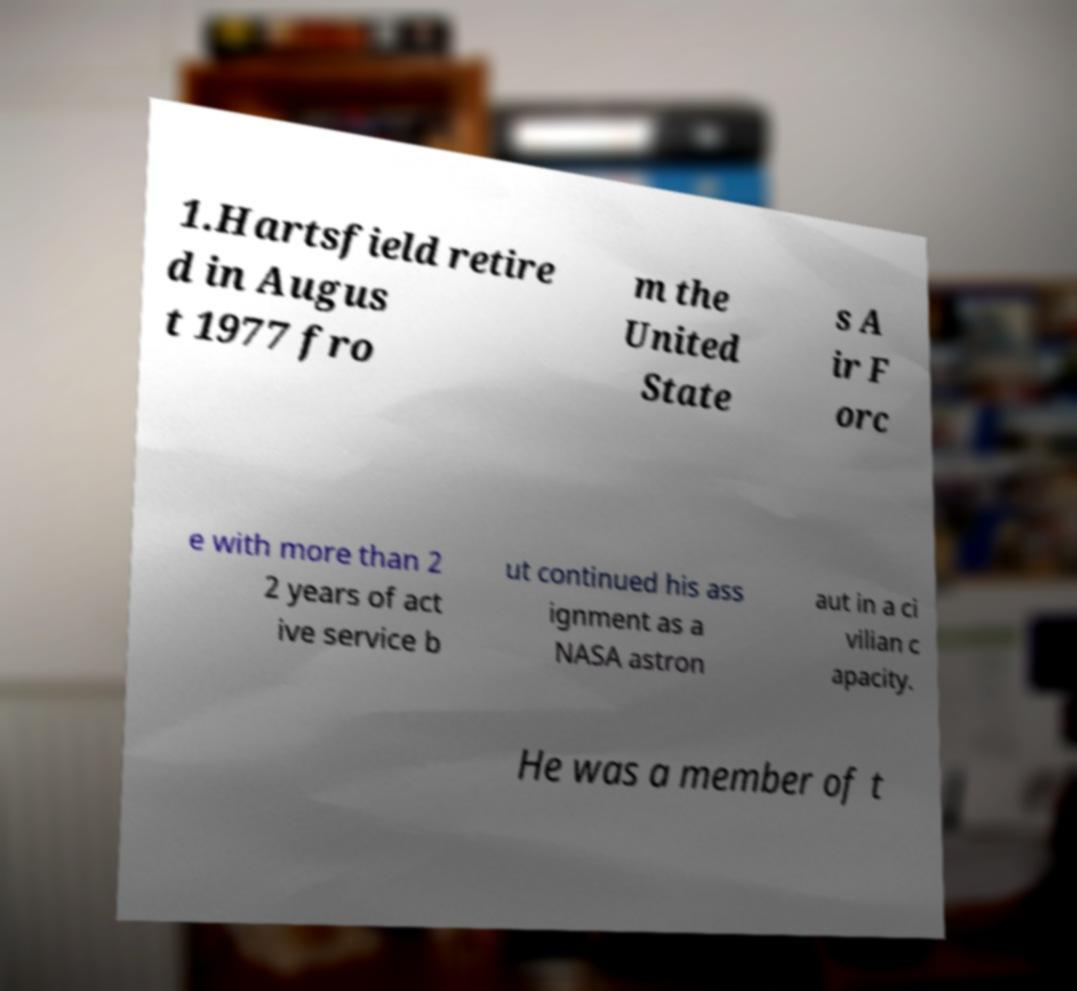Can you accurately transcribe the text from the provided image for me? 1.Hartsfield retire d in Augus t 1977 fro m the United State s A ir F orc e with more than 2 2 years of act ive service b ut continued his ass ignment as a NASA astron aut in a ci vilian c apacity. He was a member of t 